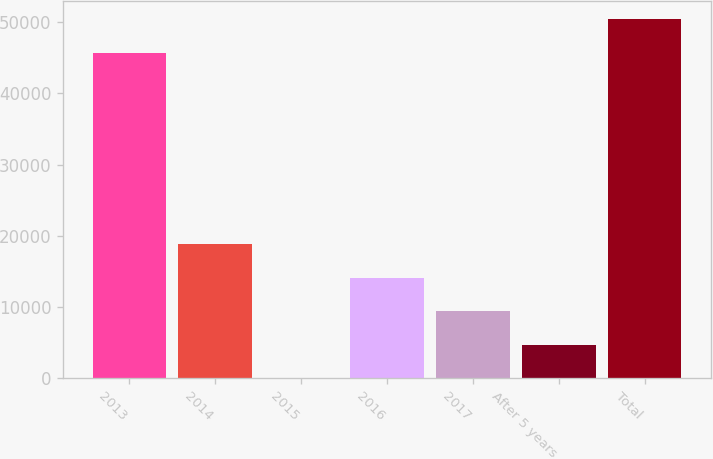<chart> <loc_0><loc_0><loc_500><loc_500><bar_chart><fcel>2013<fcel>2014<fcel>2015<fcel>2016<fcel>2017<fcel>After 5 years<fcel>Total<nl><fcel>45731<fcel>18789.6<fcel>34<fcel>14100.7<fcel>9411.8<fcel>4722.9<fcel>50419.9<nl></chart> 